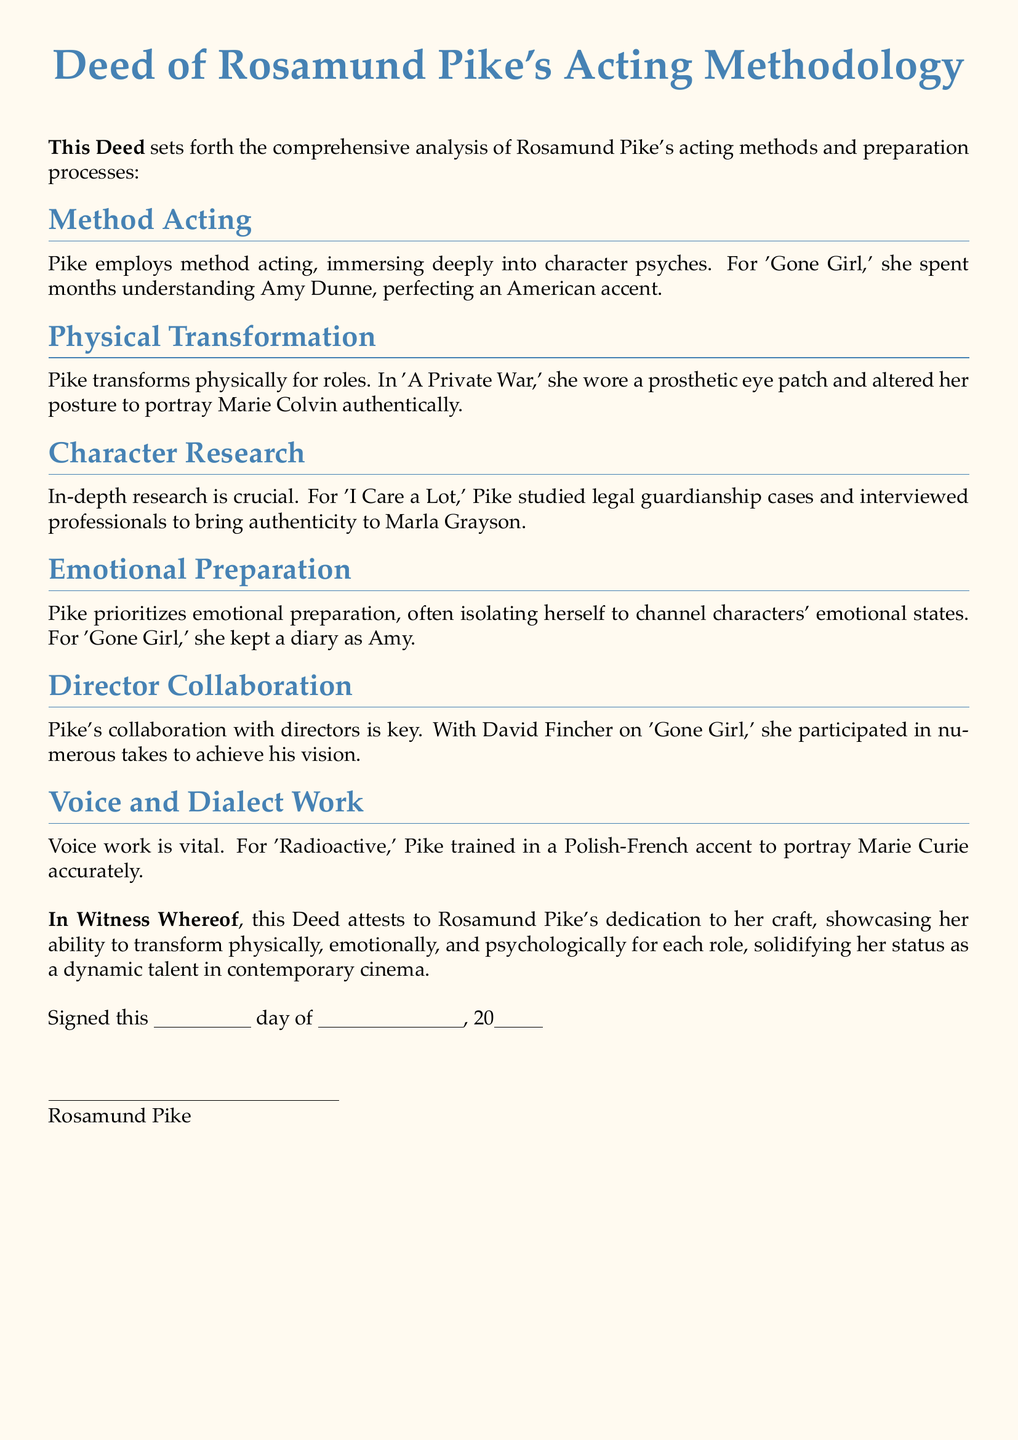What acting method does Rosamund Pike employ? The document states that Pike employs method acting, indicating her approach to deeply immerse herself into character psyches.
Answer: method acting What character did Rosamund Pike portray in 'Gone Girl'? The analysis mentions she spent months understanding Amy Dunne, her character in 'Gone Girl.'
Answer: Amy Dunne What physical transformation did Pike undergo for 'A Private War'? It is noted that she wore a prosthetic eye patch to portray Marie Colvin authentically, showcasing her physical transformation.
Answer: prosthetic eye patch What type of research did Pike conduct for 'I Care a Lot'? The document highlights that she studied legal guardianship cases and interviewed professionals, indicating the depth of her character research.
Answer: legal guardianship cases Whom did Rosamund Pike collaborate with on 'Gone Girl'? The document specifies David Fincher as her collaborator, noting the importance of her connection with the director.
Answer: David Fincher What accent did Pike train in for 'Radioactive'? It is detailed that she trained in a Polish-French accent for her role as Marie Curie in 'Radioactive.'
Answer: Polish-French accent How does Pike prioritize emotional preparation? The document describes that she often isolates herself to channel characters' emotional states, illustrating her preparation method.
Answer: isolates herself What is the purpose of keeping a diary for Pike in relation to her role? The diary was used for her emotional preparation to channel Amy's character in 'Gone Girl.'
Answer: emotional preparation On what day was this Deed signed? The document does not specify an exact day; it includes placeholders for signing, allowing for this information to be filled in later.
Answer: Not specified 